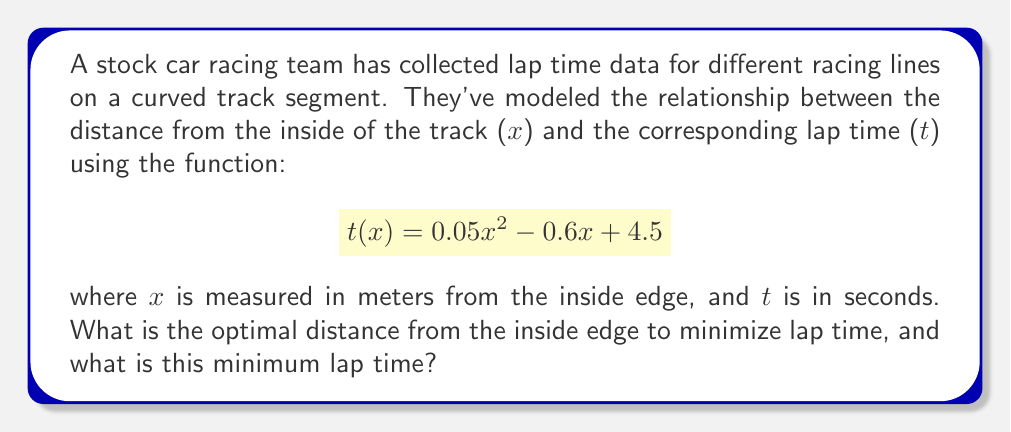Provide a solution to this math problem. To find the optimal racing line, we need to determine the minimum point of the given quadratic function. This can be done using calculus:

1) First, let's find the derivative of t(x):
   $$\frac{d}{dx}t(x) = 0.1x - 0.6$$

2) To find the minimum point, set the derivative to zero and solve for x:
   $$0.1x - 0.6 = 0$$
   $$0.1x = 0.6$$
   $$x = 6$$

3) This critical point gives us the optimal distance from the inside edge.

4) To verify it's a minimum (not a maximum), we can check the second derivative:
   $$\frac{d^2}{dx^2}t(x) = 0.1$$
   Since this is positive, we confirm it's a minimum.

5) To find the minimum lap time, we substitute x = 6 into the original function:
   $$t(6) = 0.05(6)^2 - 0.6(6) + 4.5$$
   $$= 0.05(36) - 3.6 + 4.5$$
   $$= 1.8 - 3.6 + 4.5 = 2.7$$

Therefore, the optimal distance from the inside edge is 6 meters, and the minimum lap time for this segment is 2.7 seconds.
Answer: Optimal distance: 6 meters; Minimum lap time: 2.7 seconds 